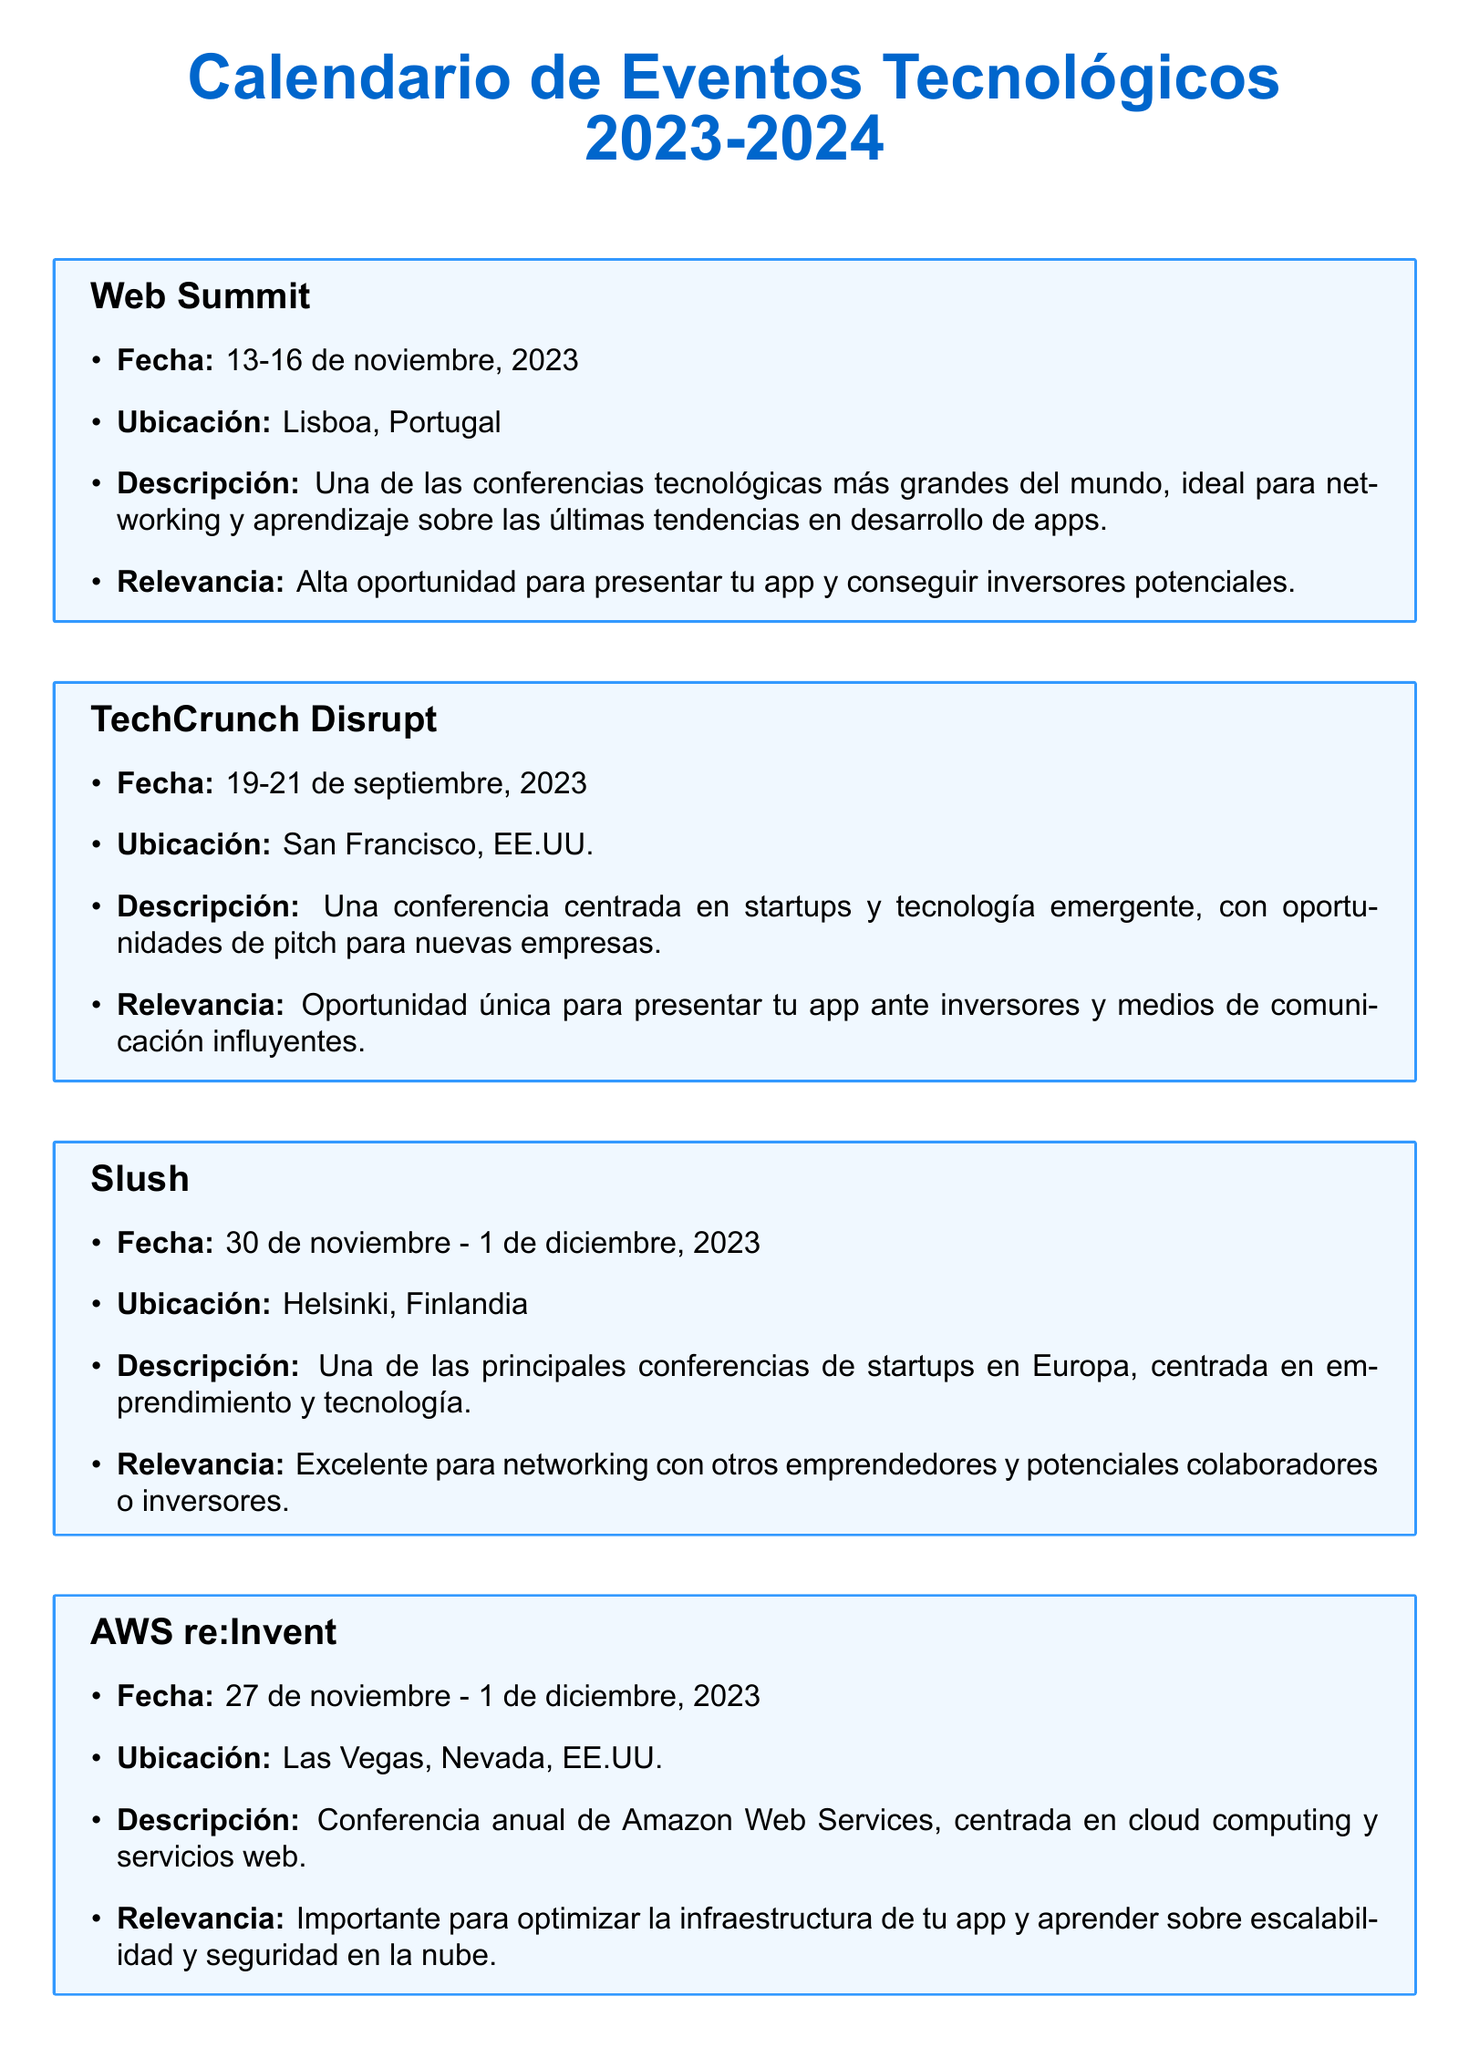¿Cuáles son las fechas del Web Summit? Las fechas del Web Summit son del 13 al 16 de noviembre de 2023.
Answer: 13-16 de noviembre, 2023 ¿Cuál es la ubicación del Mobile World Congress? La ubicación del Mobile World Congress es en Barcelona, España.
Answer: Barcelona, España ¿Qué tipo de evento es el TechCrunch Disrupt? El TechCrunch Disrupt es una conferencia centrada en startups y tecnología emergente.
Answer: Conferencia centrada en startups ¿Qué se puede aprender en la conferencia CES? En la conferencia CES se puede aprender sobre las últimas innovaciones tecnológicas.
Answer: Últimas innovaciones tecnológicas ¿Cuál es la relevancia del evento AWS re:Invent? La relevancia del evento AWS re:Invent es optimizar la infraestructura de la app y aprender sobre escalabilidad y seguridad en la nube.
Answer: Optimizar la infraestructura de tu app ¿Cuándo se celebrará la conferencia Google I/O? La conferencia Google I/O se celebrará en mayo de 2024, con fecha exacta por confirmar.
Answer: Mayo 2024 ¿Qué es el Slush? El Slush es una de las principales conferencias de startups en Europa.
Answer: Conferencia de startups ¿Cuánto dura el Mobile World Congress? El Mobile World Congress dura cuatro días.
Answer: Cuatro días 